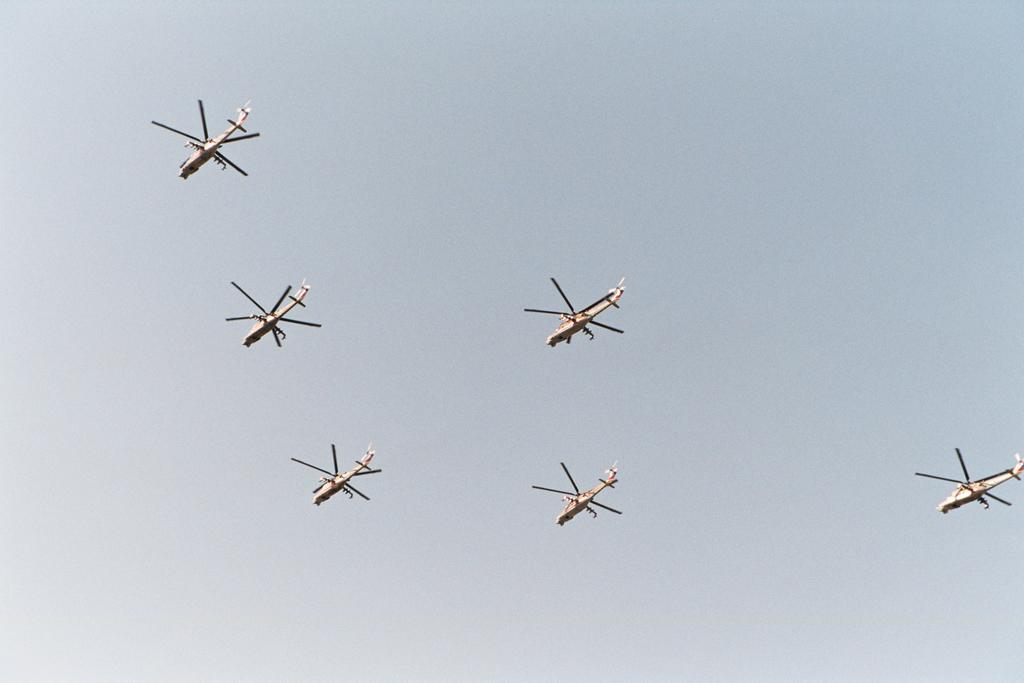How many helicopters are visible in the image? There are six helicopters in the image. What are the helicopters doing in the image? The helicopters are flying in the sky. What type of stocking is being worn by the helicopter in the image? There are no stockings present in the image, as it features helicopters flying in the sky. 